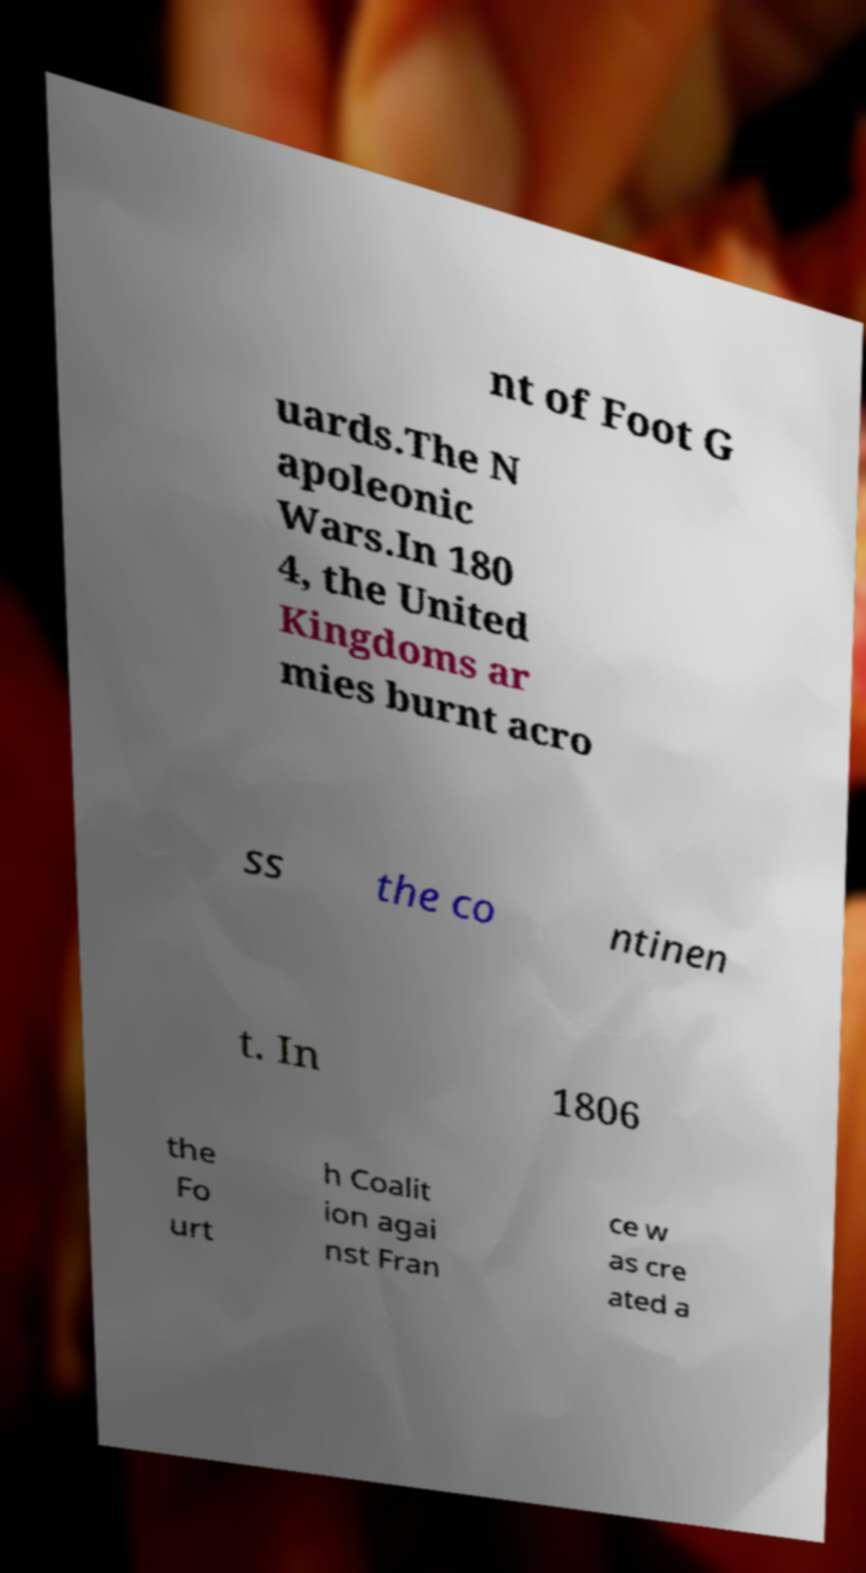Can you accurately transcribe the text from the provided image for me? nt of Foot G uards.The N apoleonic Wars.In 180 4, the United Kingdoms ar mies burnt acro ss the co ntinen t. In 1806 the Fo urt h Coalit ion agai nst Fran ce w as cre ated a 